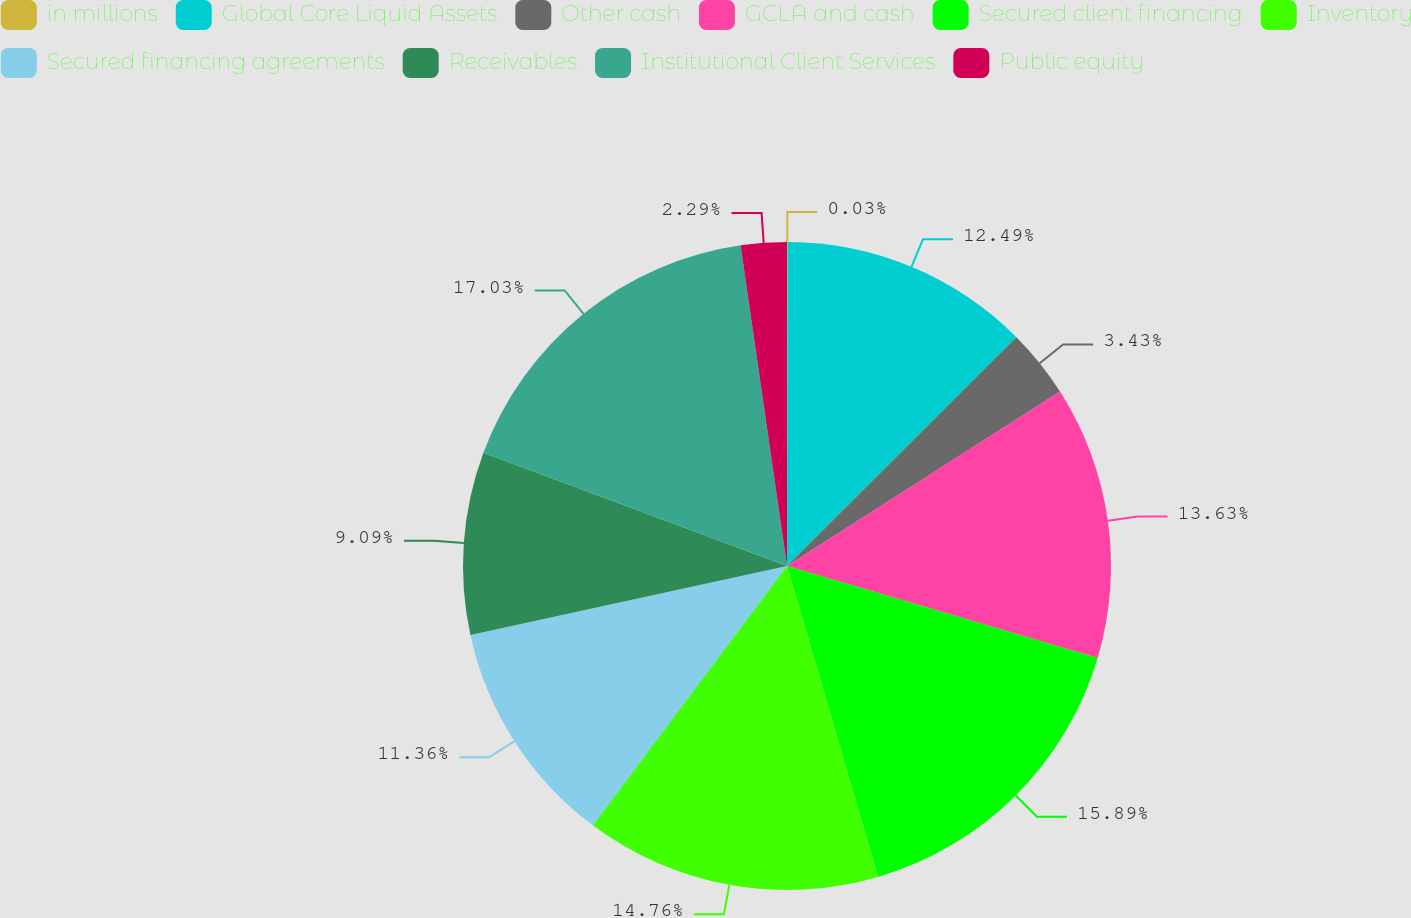<chart> <loc_0><loc_0><loc_500><loc_500><pie_chart><fcel>in millions<fcel>Global Core Liquid Assets<fcel>Other cash<fcel>GCLA and cash<fcel>Secured client financing<fcel>Inventory<fcel>Secured financing agreements<fcel>Receivables<fcel>Institutional Client Services<fcel>Public equity<nl><fcel>0.03%<fcel>12.49%<fcel>3.43%<fcel>13.63%<fcel>15.89%<fcel>14.76%<fcel>11.36%<fcel>9.09%<fcel>17.03%<fcel>2.29%<nl></chart> 